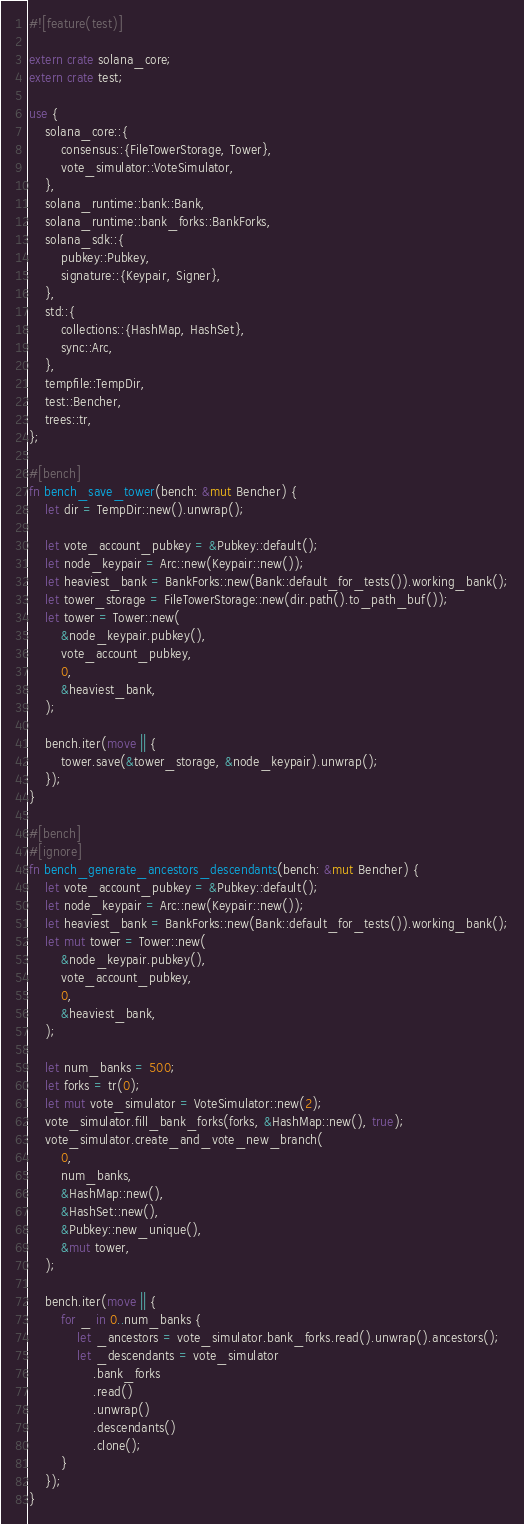<code> <loc_0><loc_0><loc_500><loc_500><_Rust_>#![feature(test)]

extern crate solana_core;
extern crate test;

use {
    solana_core::{
        consensus::{FileTowerStorage, Tower},
        vote_simulator::VoteSimulator,
    },
    solana_runtime::bank::Bank,
    solana_runtime::bank_forks::BankForks,
    solana_sdk::{
        pubkey::Pubkey,
        signature::{Keypair, Signer},
    },
    std::{
        collections::{HashMap, HashSet},
        sync::Arc,
    },
    tempfile::TempDir,
    test::Bencher,
    trees::tr,
};

#[bench]
fn bench_save_tower(bench: &mut Bencher) {
    let dir = TempDir::new().unwrap();

    let vote_account_pubkey = &Pubkey::default();
    let node_keypair = Arc::new(Keypair::new());
    let heaviest_bank = BankForks::new(Bank::default_for_tests()).working_bank();
    let tower_storage = FileTowerStorage::new(dir.path().to_path_buf());
    let tower = Tower::new(
        &node_keypair.pubkey(),
        vote_account_pubkey,
        0,
        &heaviest_bank,
    );

    bench.iter(move || {
        tower.save(&tower_storage, &node_keypair).unwrap();
    });
}

#[bench]
#[ignore]
fn bench_generate_ancestors_descendants(bench: &mut Bencher) {
    let vote_account_pubkey = &Pubkey::default();
    let node_keypair = Arc::new(Keypair::new());
    let heaviest_bank = BankForks::new(Bank::default_for_tests()).working_bank();
    let mut tower = Tower::new(
        &node_keypair.pubkey(),
        vote_account_pubkey,
        0,
        &heaviest_bank,
    );

    let num_banks = 500;
    let forks = tr(0);
    let mut vote_simulator = VoteSimulator::new(2);
    vote_simulator.fill_bank_forks(forks, &HashMap::new(), true);
    vote_simulator.create_and_vote_new_branch(
        0,
        num_banks,
        &HashMap::new(),
        &HashSet::new(),
        &Pubkey::new_unique(),
        &mut tower,
    );

    bench.iter(move || {
        for _ in 0..num_banks {
            let _ancestors = vote_simulator.bank_forks.read().unwrap().ancestors();
            let _descendants = vote_simulator
                .bank_forks
                .read()
                .unwrap()
                .descendants()
                .clone();
        }
    });
}
</code> 